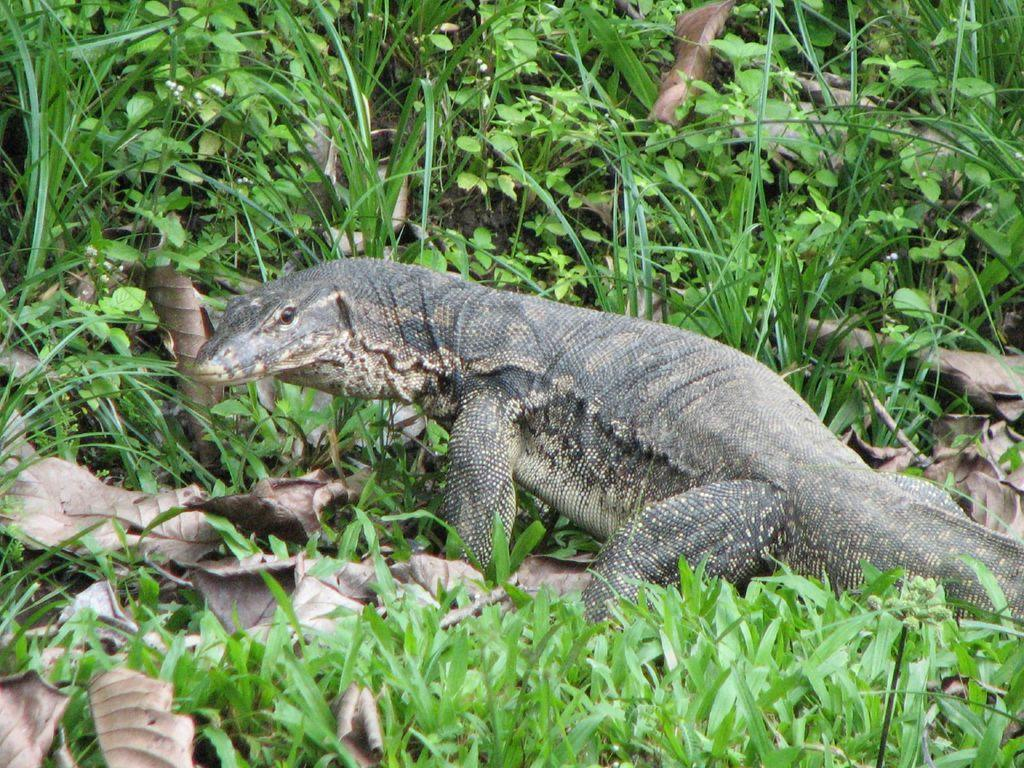What type of animal is in the image? There is a monitor lizard in the image. What else can be seen in the image besides the animal? There are plants visible in the image. What is visible in the background of the image? The sky is visible in the image. What type of letter is the cow holding in the image? There is no cow or letter present in the image; it features a monitor lizard and plants. Can you see a shoe in the image? There is no shoe present in the image. 